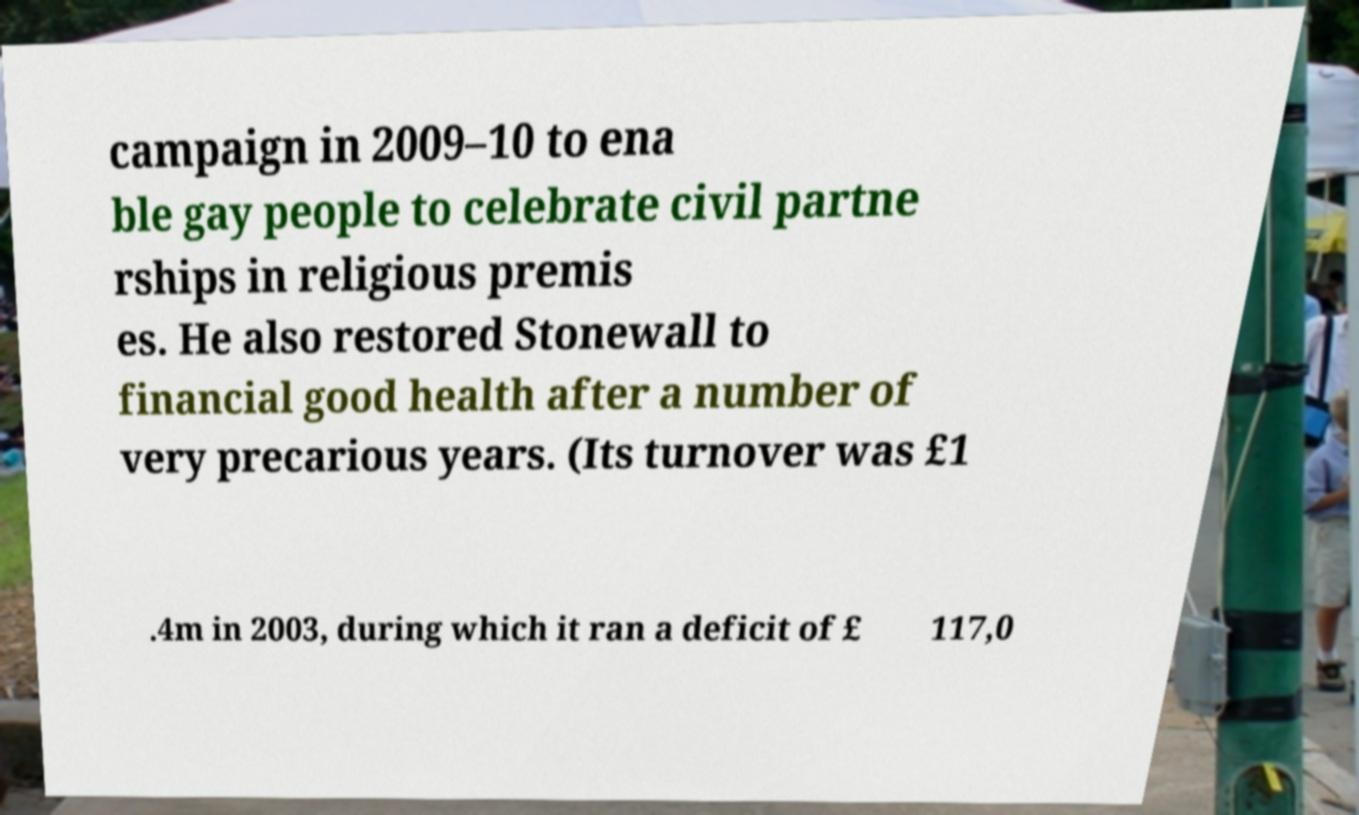Can you read and provide the text displayed in the image?This photo seems to have some interesting text. Can you extract and type it out for me? campaign in 2009–10 to ena ble gay people to celebrate civil partne rships in religious premis es. He also restored Stonewall to financial good health after a number of very precarious years. (Its turnover was £1 .4m in 2003, during which it ran a deficit of £ 117,0 